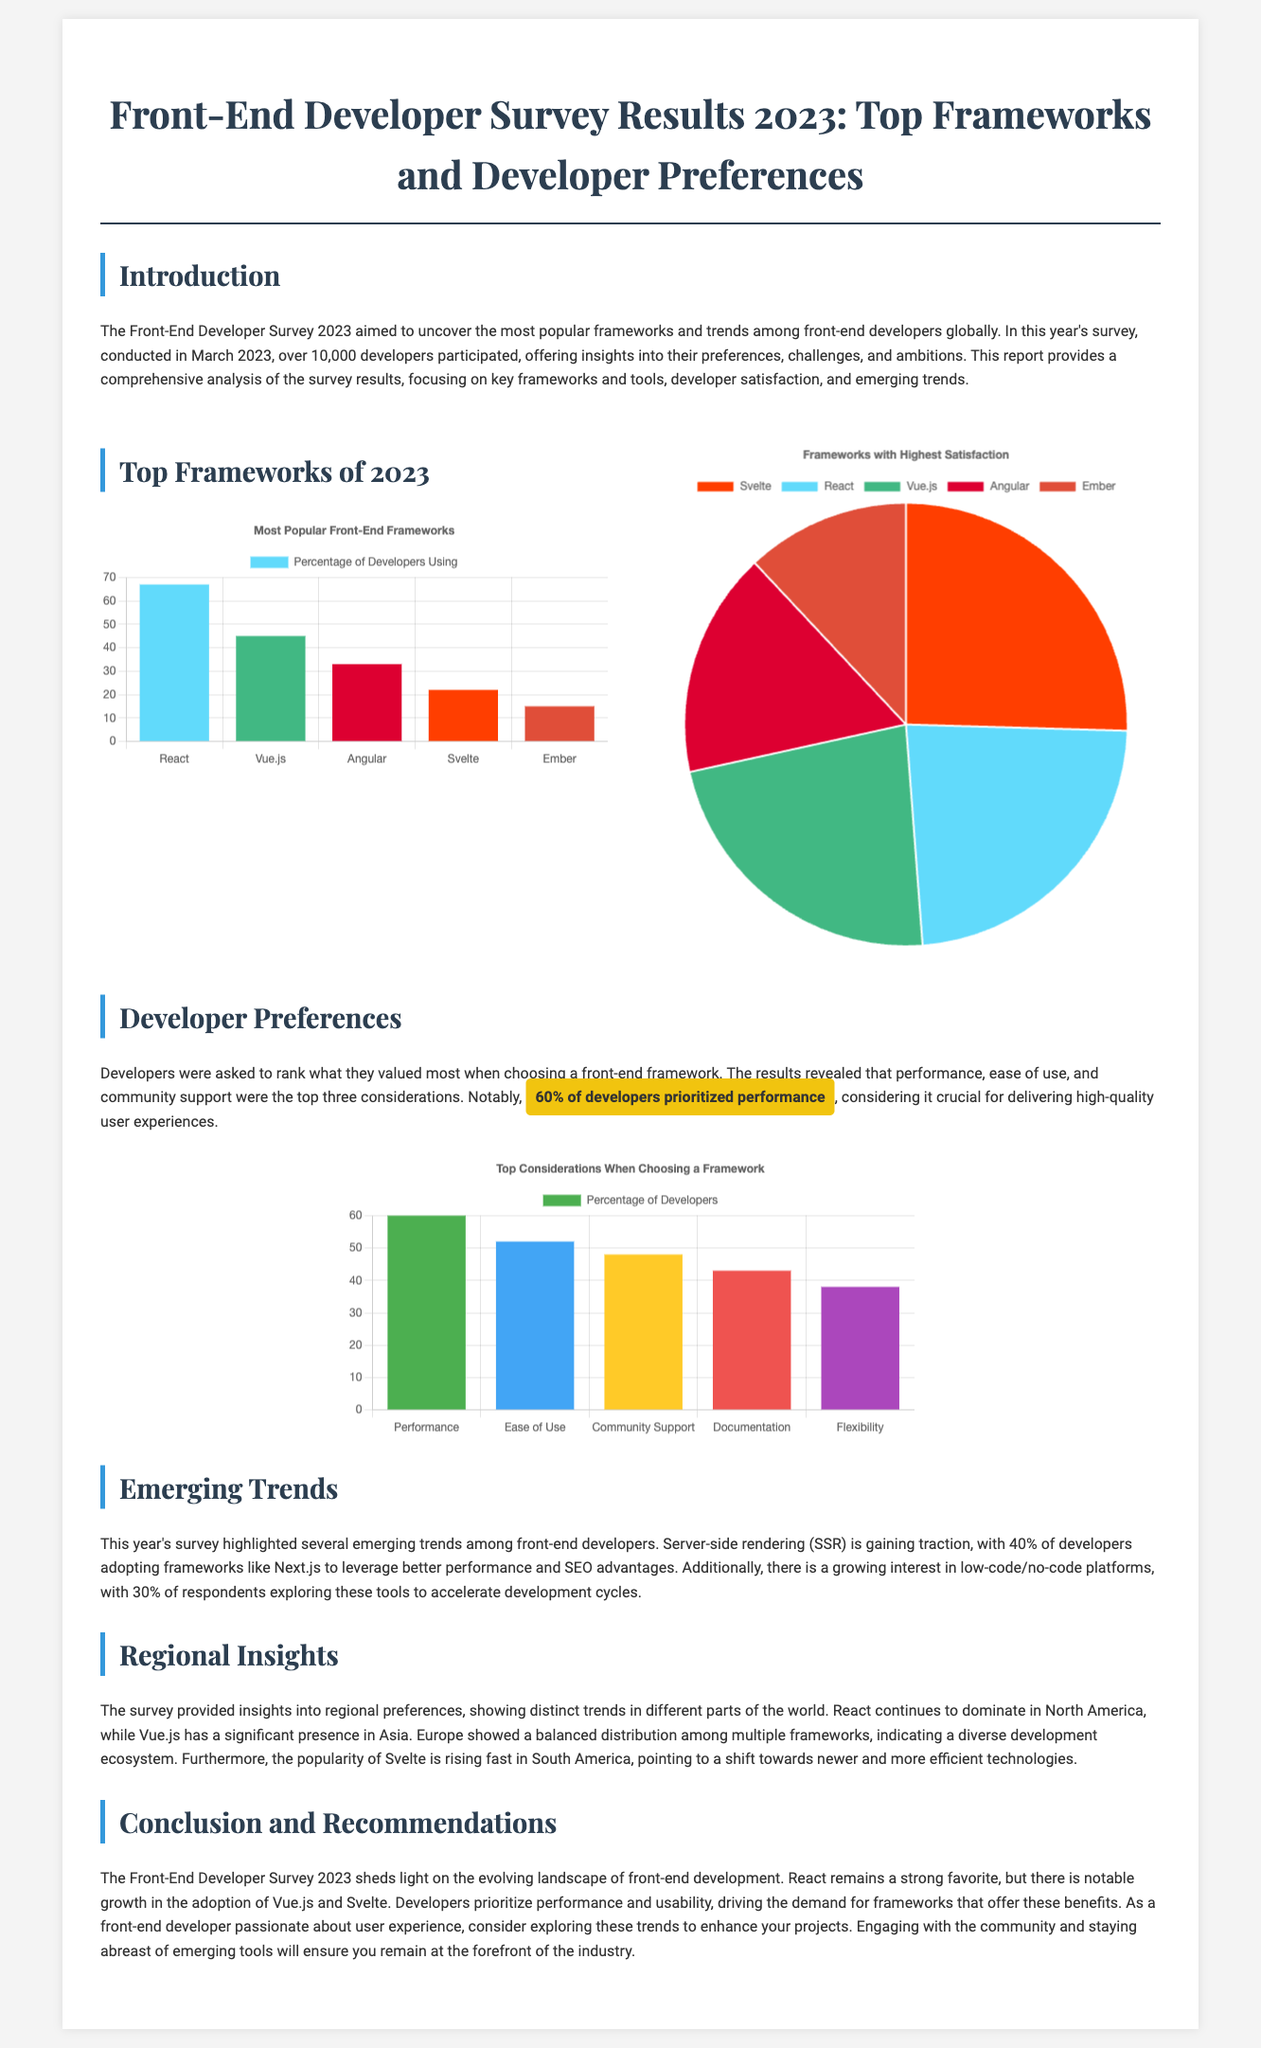What was the size of the survey sample? The survey sample included over 10,000 developers.
Answer: over 10,000 developers What are the top three frameworks based on the percentage of developers using them? The top three frameworks are identified based on the bar chart showing their usage percentages.
Answer: React, Vue.js, Angular Which framework has the highest satisfaction rating according to the survey? The satisfaction ratings are represented in a pie chart, highlighting satisfaction levels of each framework.
Answer: Svelte What percentage of developers prioritized performance when choosing a framework? The document states that 60% of developers prioritized performance as their top consideration.
Answer: 60% Which emerging trend involves frameworks like Next.js? The survey highlights server-side rendering (SSR) as an emerging trend among developers.
Answer: Server-side rendering (SSR) What region showed a growing popularity for Svelte? The document mentions that Svelte is rising rapidly in South America based on regional insights.
Answer: South America What is the total number of developers who consider ease of use important? From the considerations chart, ease of use is ranked among developers’ values but specific total number isn't given.
Answer: 52% What visual representation is used to show the most popular front-end frameworks? The most popular frameworks are represented using a bar chart.
Answer: Bar chart 